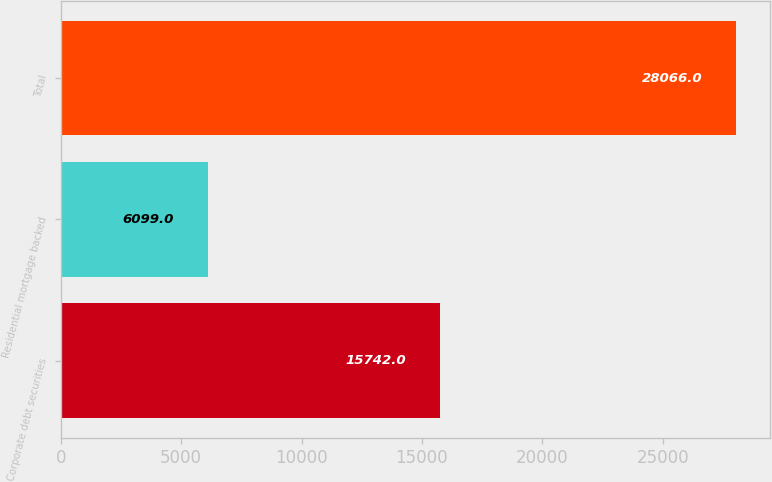<chart> <loc_0><loc_0><loc_500><loc_500><bar_chart><fcel>Corporate debt securities<fcel>Residential mortgage backed<fcel>Total<nl><fcel>15742<fcel>6099<fcel>28066<nl></chart> 